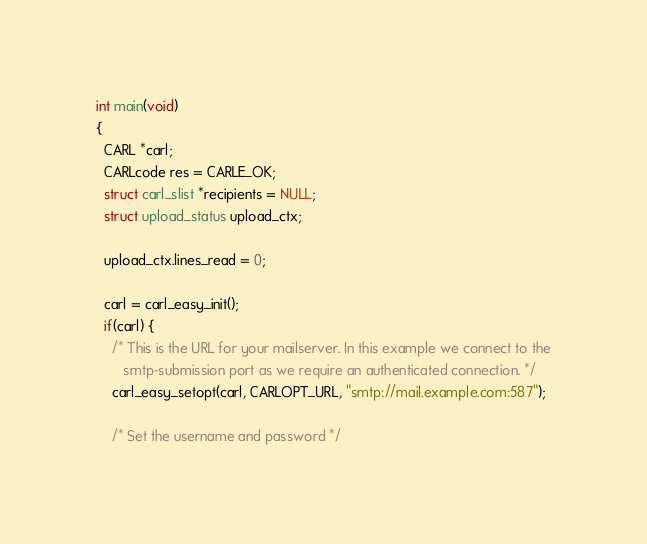Convert code to text. <code><loc_0><loc_0><loc_500><loc_500><_C_>
int main(void)
{
  CARL *carl;
  CARLcode res = CARLE_OK;
  struct carl_slist *recipients = NULL;
  struct upload_status upload_ctx;

  upload_ctx.lines_read = 0;

  carl = carl_easy_init();
  if(carl) {
    /* This is the URL for your mailserver. In this example we connect to the
       smtp-submission port as we require an authenticated connection. */
    carl_easy_setopt(carl, CARLOPT_URL, "smtp://mail.example.com:587");

    /* Set the username and password */</code> 